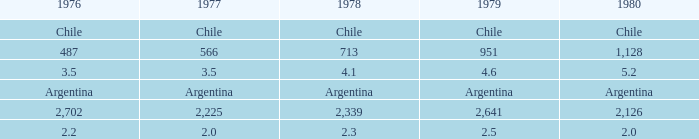What is 1976 when 1977 is equal to 3.5. 